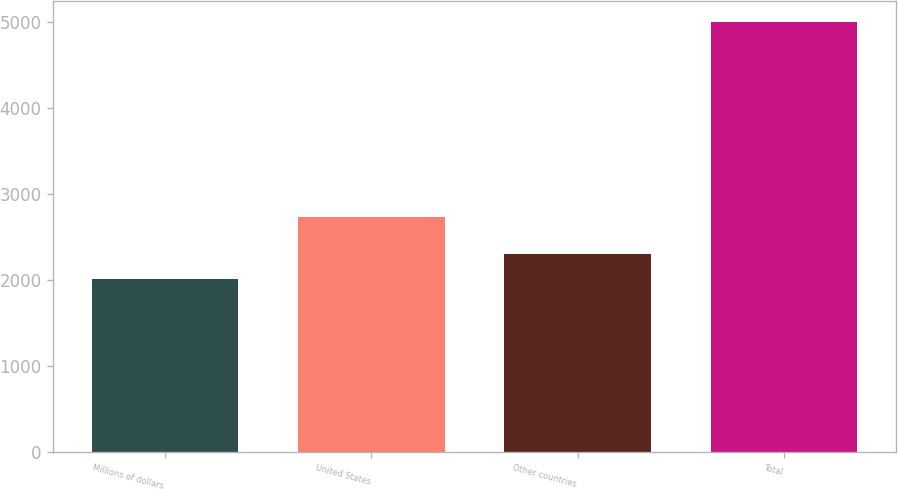Convert chart to OTSL. <chart><loc_0><loc_0><loc_500><loc_500><bar_chart><fcel>Millions of dollars<fcel>United States<fcel>Other countries<fcel>Total<nl><fcel>2007<fcel>2733<fcel>2305.9<fcel>4996<nl></chart> 